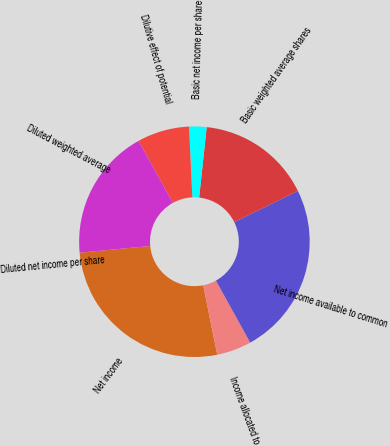<chart> <loc_0><loc_0><loc_500><loc_500><pie_chart><fcel>Net income<fcel>Income allocated to<fcel>Net income available to common<fcel>Basic weighted average shares<fcel>Basic net income per share<fcel>Dilutive effect of potential<fcel>Diluted weighted average<fcel>Diluted net income per share<nl><fcel>26.66%<fcel>4.87%<fcel>24.23%<fcel>16.03%<fcel>2.44%<fcel>7.31%<fcel>18.47%<fcel>0.0%<nl></chart> 